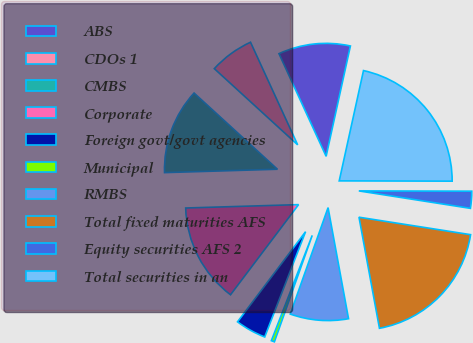Convert chart. <chart><loc_0><loc_0><loc_500><loc_500><pie_chart><fcel>ABS<fcel>CDOs 1<fcel>CMBS<fcel>Corporate<fcel>Foreign govt/govt agencies<fcel>Municipal<fcel>RMBS<fcel>Total fixed maturities AFS<fcel>Equity securities AFS 2<fcel>Total securities in an<nl><fcel>10.3%<fcel>6.36%<fcel>12.26%<fcel>14.23%<fcel>4.4%<fcel>0.46%<fcel>8.33%<fcel>19.63%<fcel>2.43%<fcel>21.59%<nl></chart> 